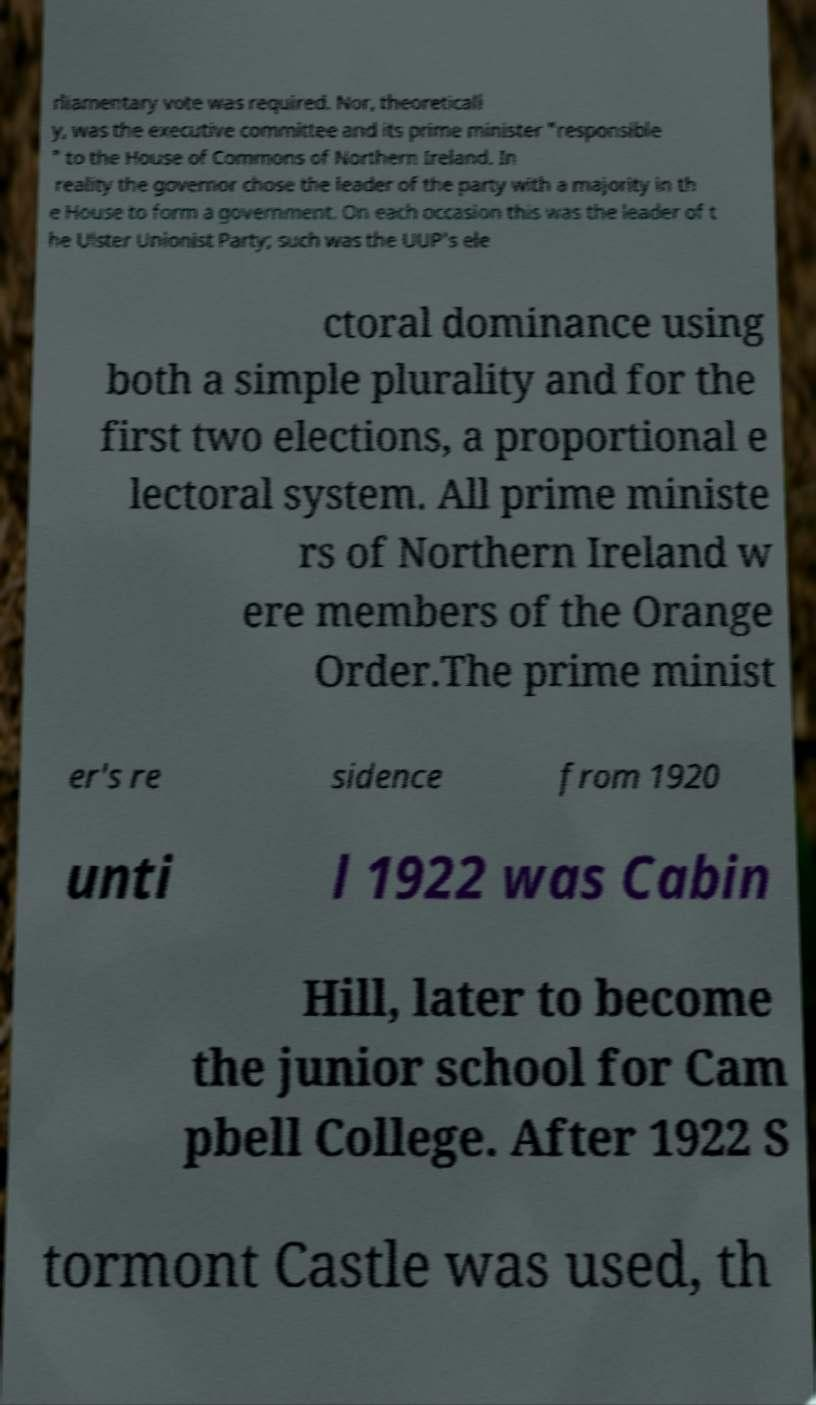Could you assist in decoding the text presented in this image and type it out clearly? rliamentary vote was required. Nor, theoreticall y, was the executive committee and its prime minister "responsible " to the House of Commons of Northern Ireland. In reality the governor chose the leader of the party with a majority in th e House to form a government. On each occasion this was the leader of t he Ulster Unionist Party; such was the UUP's ele ctoral dominance using both a simple plurality and for the first two elections, a proportional e lectoral system. All prime ministe rs of Northern Ireland w ere members of the Orange Order.The prime minist er's re sidence from 1920 unti l 1922 was Cabin Hill, later to become the junior school for Cam pbell College. After 1922 S tormont Castle was used, th 